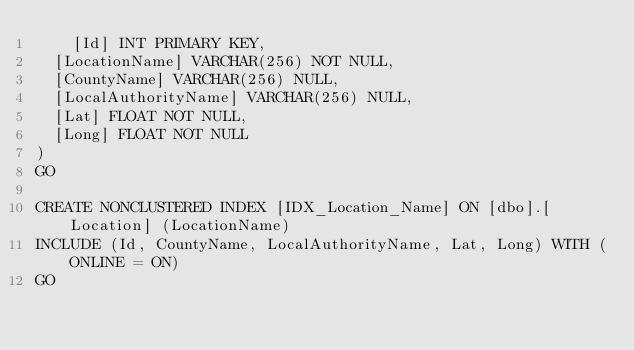<code> <loc_0><loc_0><loc_500><loc_500><_SQL_>    [Id] INT PRIMARY KEY,
	[LocationName] VARCHAR(256) NOT NULL,
	[CountyName] VARCHAR(256) NULL,
	[LocalAuthorityName] VARCHAR(256) NULL,
	[Lat] FLOAT NOT NULL,
	[Long] FLOAT NOT NULL
)
GO

CREATE NONCLUSTERED INDEX [IDX_Location_Name] ON [dbo].[Location] (LocationName) 
INCLUDE (Id, CountyName, LocalAuthorityName, Lat, Long) WITH (ONLINE = ON) 
GO </code> 